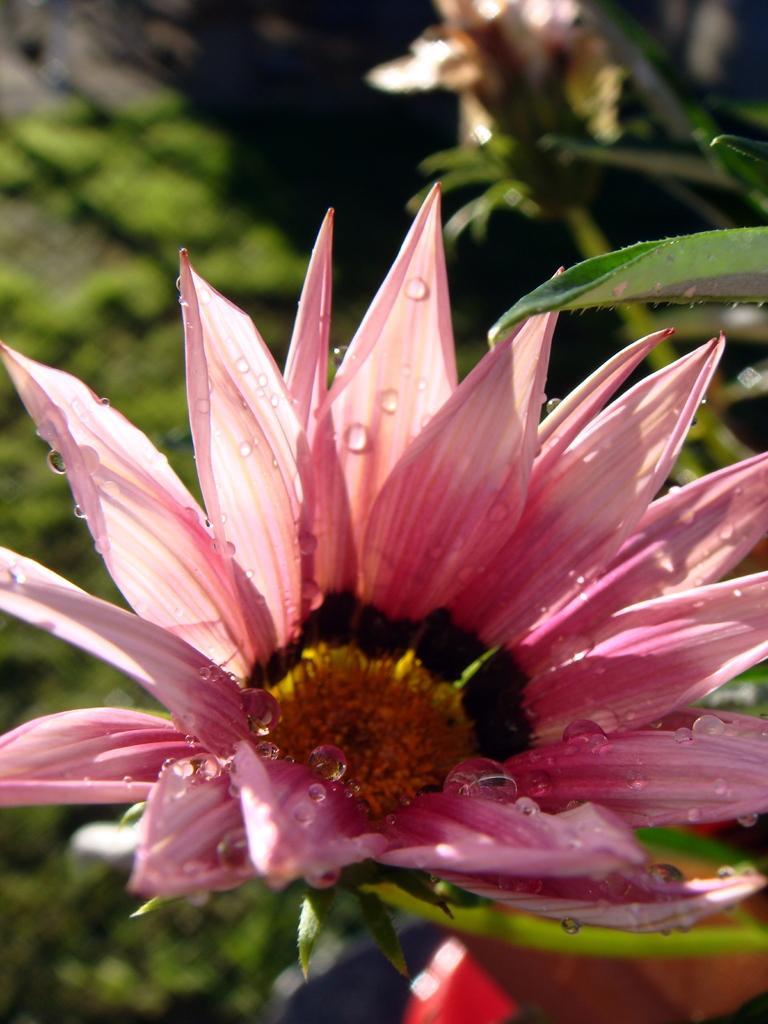Could you give a brief overview of what you see in this image? We can see pink flower and green leaves. In the background it is blur. 